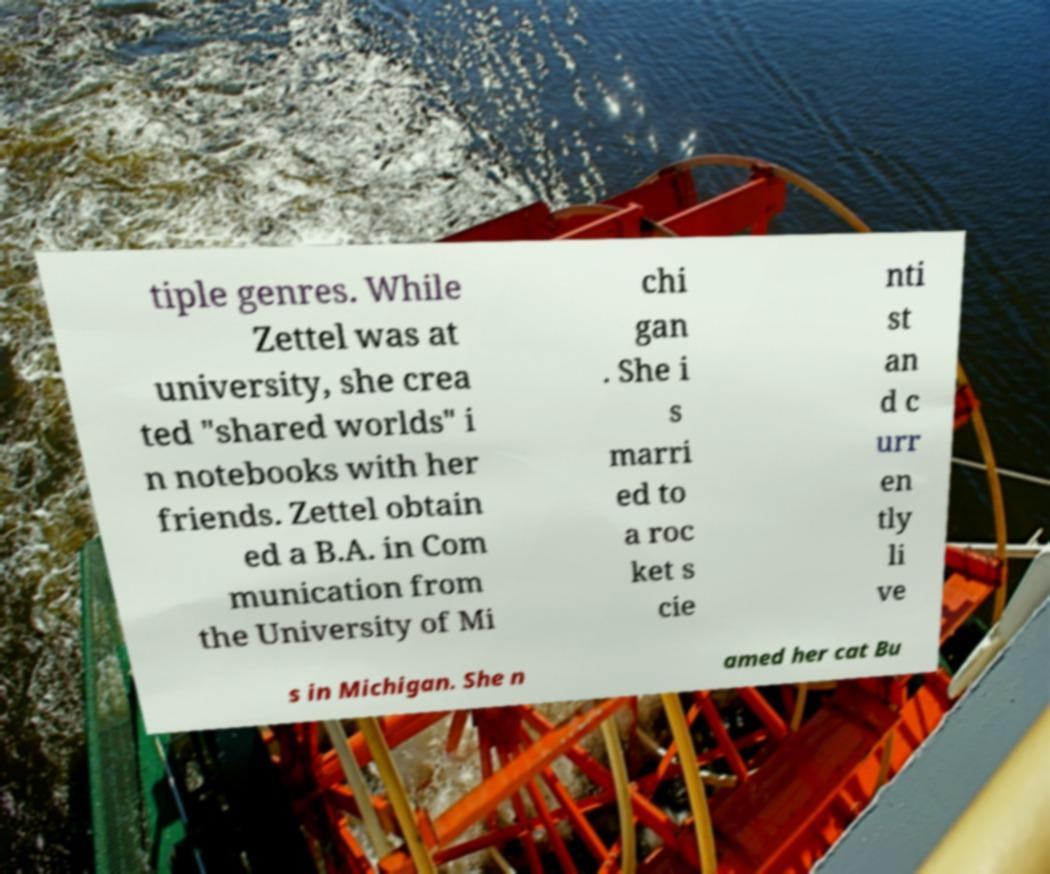There's text embedded in this image that I need extracted. Can you transcribe it verbatim? tiple genres. While Zettel was at university, she crea ted "shared worlds" i n notebooks with her friends. Zettel obtain ed a B.A. in Com munication from the University of Mi chi gan . She i s marri ed to a roc ket s cie nti st an d c urr en tly li ve s in Michigan. She n amed her cat Bu 